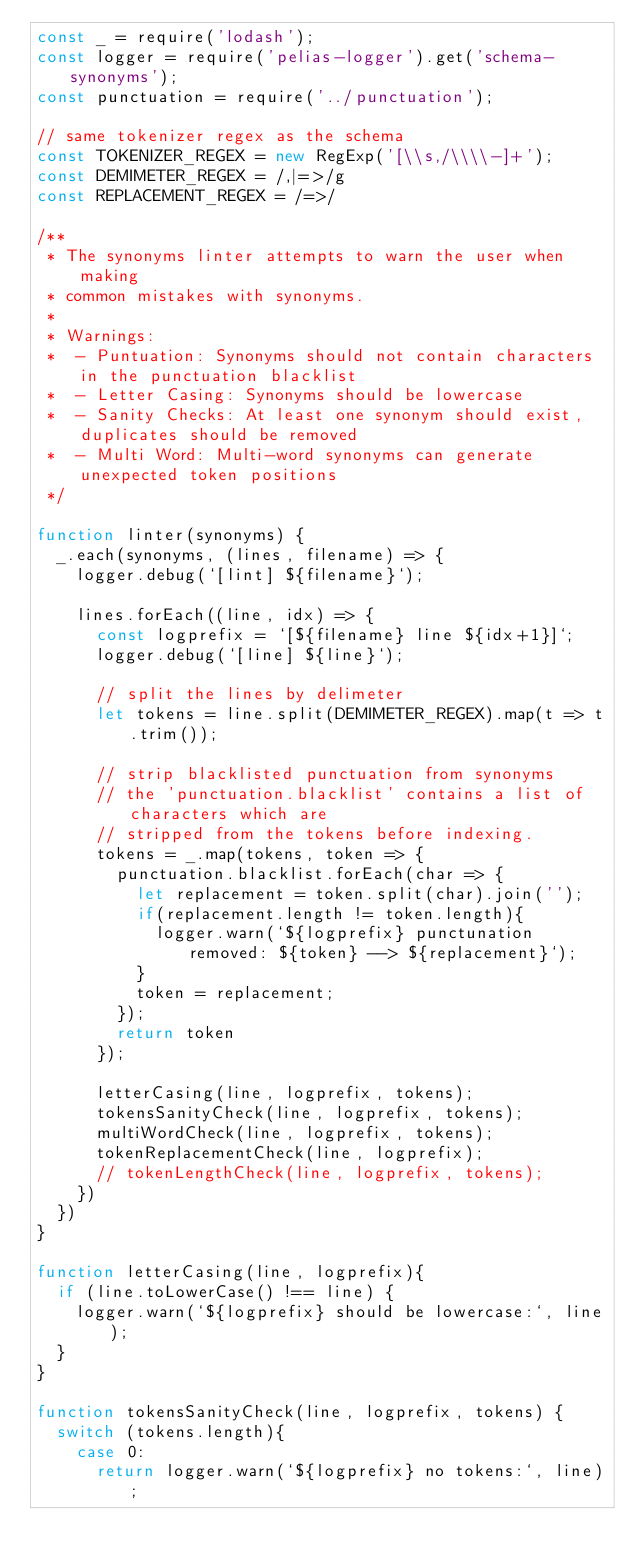Convert code to text. <code><loc_0><loc_0><loc_500><loc_500><_JavaScript_>const _ = require('lodash');
const logger = require('pelias-logger').get('schema-synonyms');
const punctuation = require('../punctuation');

// same tokenizer regex as the schema
const TOKENIZER_REGEX = new RegExp('[\\s,/\\\\-]+');
const DEMIMETER_REGEX = /,|=>/g
const REPLACEMENT_REGEX = /=>/

/**
 * The synonyms linter attempts to warn the user when making
 * common mistakes with synonyms.
 *
 * Warnings:
 *  - Puntuation: Synonyms should not contain characters in the punctuation blacklist
 *  - Letter Casing: Synonyms should be lowercase
 *  - Sanity Checks: At least one synonym should exist, duplicates should be removed
 *  - Multi Word: Multi-word synonyms can generate unexpected token positions
 */

function linter(synonyms) {
  _.each(synonyms, (lines, filename) => {
    logger.debug(`[lint] ${filename}`);

    lines.forEach((line, idx) => {
      const logprefix = `[${filename} line ${idx+1}]`;
      logger.debug(`[line] ${line}`);

      // split the lines by delimeter
      let tokens = line.split(DEMIMETER_REGEX).map(t => t.trim());

      // strip blacklisted punctuation from synonyms
      // the 'punctuation.blacklist' contains a list of characters which are
      // stripped from the tokens before indexing.
      tokens = _.map(tokens, token => {
        punctuation.blacklist.forEach(char => {
          let replacement = token.split(char).join('');
          if(replacement.length != token.length){
            logger.warn(`${logprefix} punctunation removed: ${token} --> ${replacement}`);
          }
          token = replacement;
        });
        return token
      });

      letterCasing(line, logprefix, tokens);
      tokensSanityCheck(line, logprefix, tokens);
      multiWordCheck(line, logprefix, tokens);
      tokenReplacementCheck(line, logprefix);
      // tokenLengthCheck(line, logprefix, tokens);
    })
  })
}

function letterCasing(line, logprefix){
  if (line.toLowerCase() !== line) {
    logger.warn(`${logprefix} should be lowercase:`, line);
  }
}

function tokensSanityCheck(line, logprefix, tokens) {
  switch (tokens.length){
    case 0:
      return logger.warn(`${logprefix} no tokens:`, line);</code> 